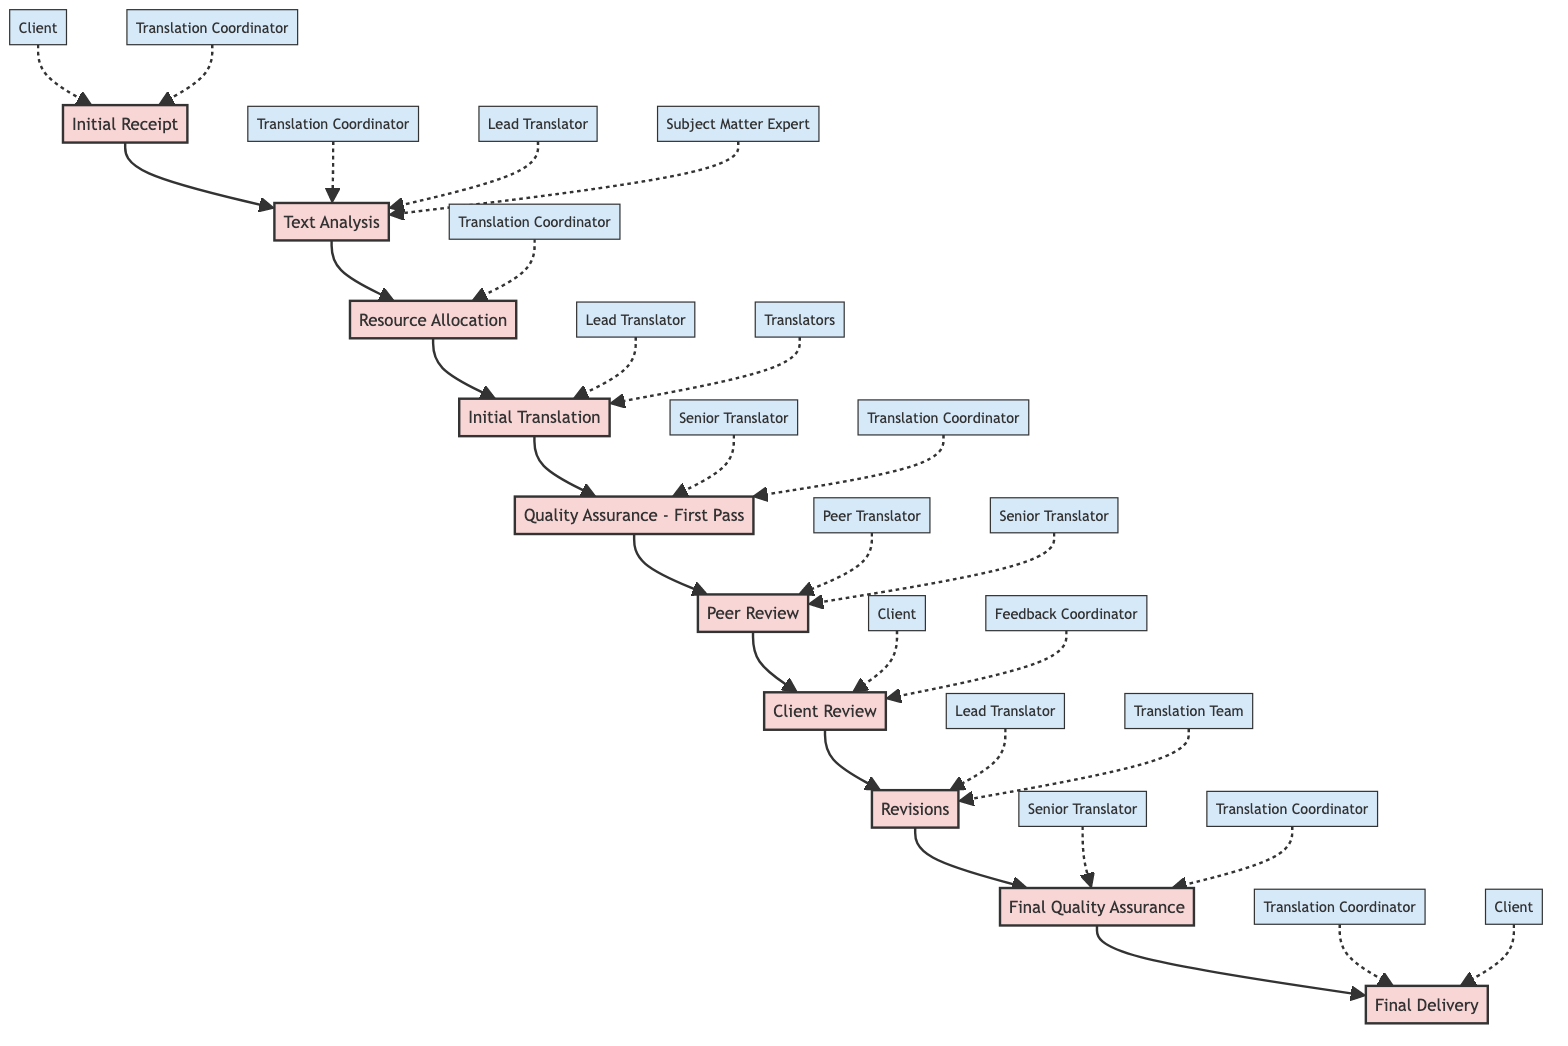What is the first block in the workflow process? The first block in the workflow process is "Initial Receipt". It can be identified as it is the starting point of the flowchart, leading to the next block "Text Analysis".
Answer: Initial Receipt How many blocks are there in total? Counting all distinct blocks from "Initial Receipt" to "Final Delivery", there are 10 blocks in total. This includes all the stages listed in the diagram.
Answer: 10 Which block follows "Peer Review"? "Client Review" follows "Peer Review" in the flow of the diagram. It can be found by tracing the connection from "Peer Review" to the next stage.
Answer: Client Review Who is involved in the "Text Analysis" block? The individuals involved in the "Text Analysis" block are "Translation Coordinator", "Lead Translator", and "Subject Matter Expert". They are all illustrated by contribution arrows pointing to the "Text Analysis" block.
Answer: Translation Coordinator, Lead Translator, Subject Matter Expert What is the final stage in the workflow process? The final stage in the workflow process is "Final Delivery". This is the last block and signifies the completion of the translation process.
Answer: Final Delivery After which block does "Client Review" occur? "Client Review" occurs after "Peer Review". By following the progression of the blocks, it is clear that "Client Review" directly comes after the "Peer Review" stage.
Answer: Peer Review Which roles contribute to the "Revisions" block? The roles contributing to the "Revisions" block are "Lead Translator" and "Translation Team". Their contributions can be found as they have arrows pointing to the "Revisions" block in the diagram.
Answer: Lead Translator, Translation Team Which block has the most contributors? The "Text Analysis" block has the most contributors, with three roles identified as contributing to it: "Translation Coordinator", "Lead Translator", and "Subject Matter Expert". This is the highest count among all blocks.
Answer: Text Analysis What is the relationship between "Initial Translation" and "Quality Assurance - First Pass"? The relationship is sequential, meaning "Initial Translation" directly leads to "Quality Assurance - First Pass" in the workflow. This can be seen by the arrow connecting the two blocks in the diagram.
Answer: Sequential relationship 